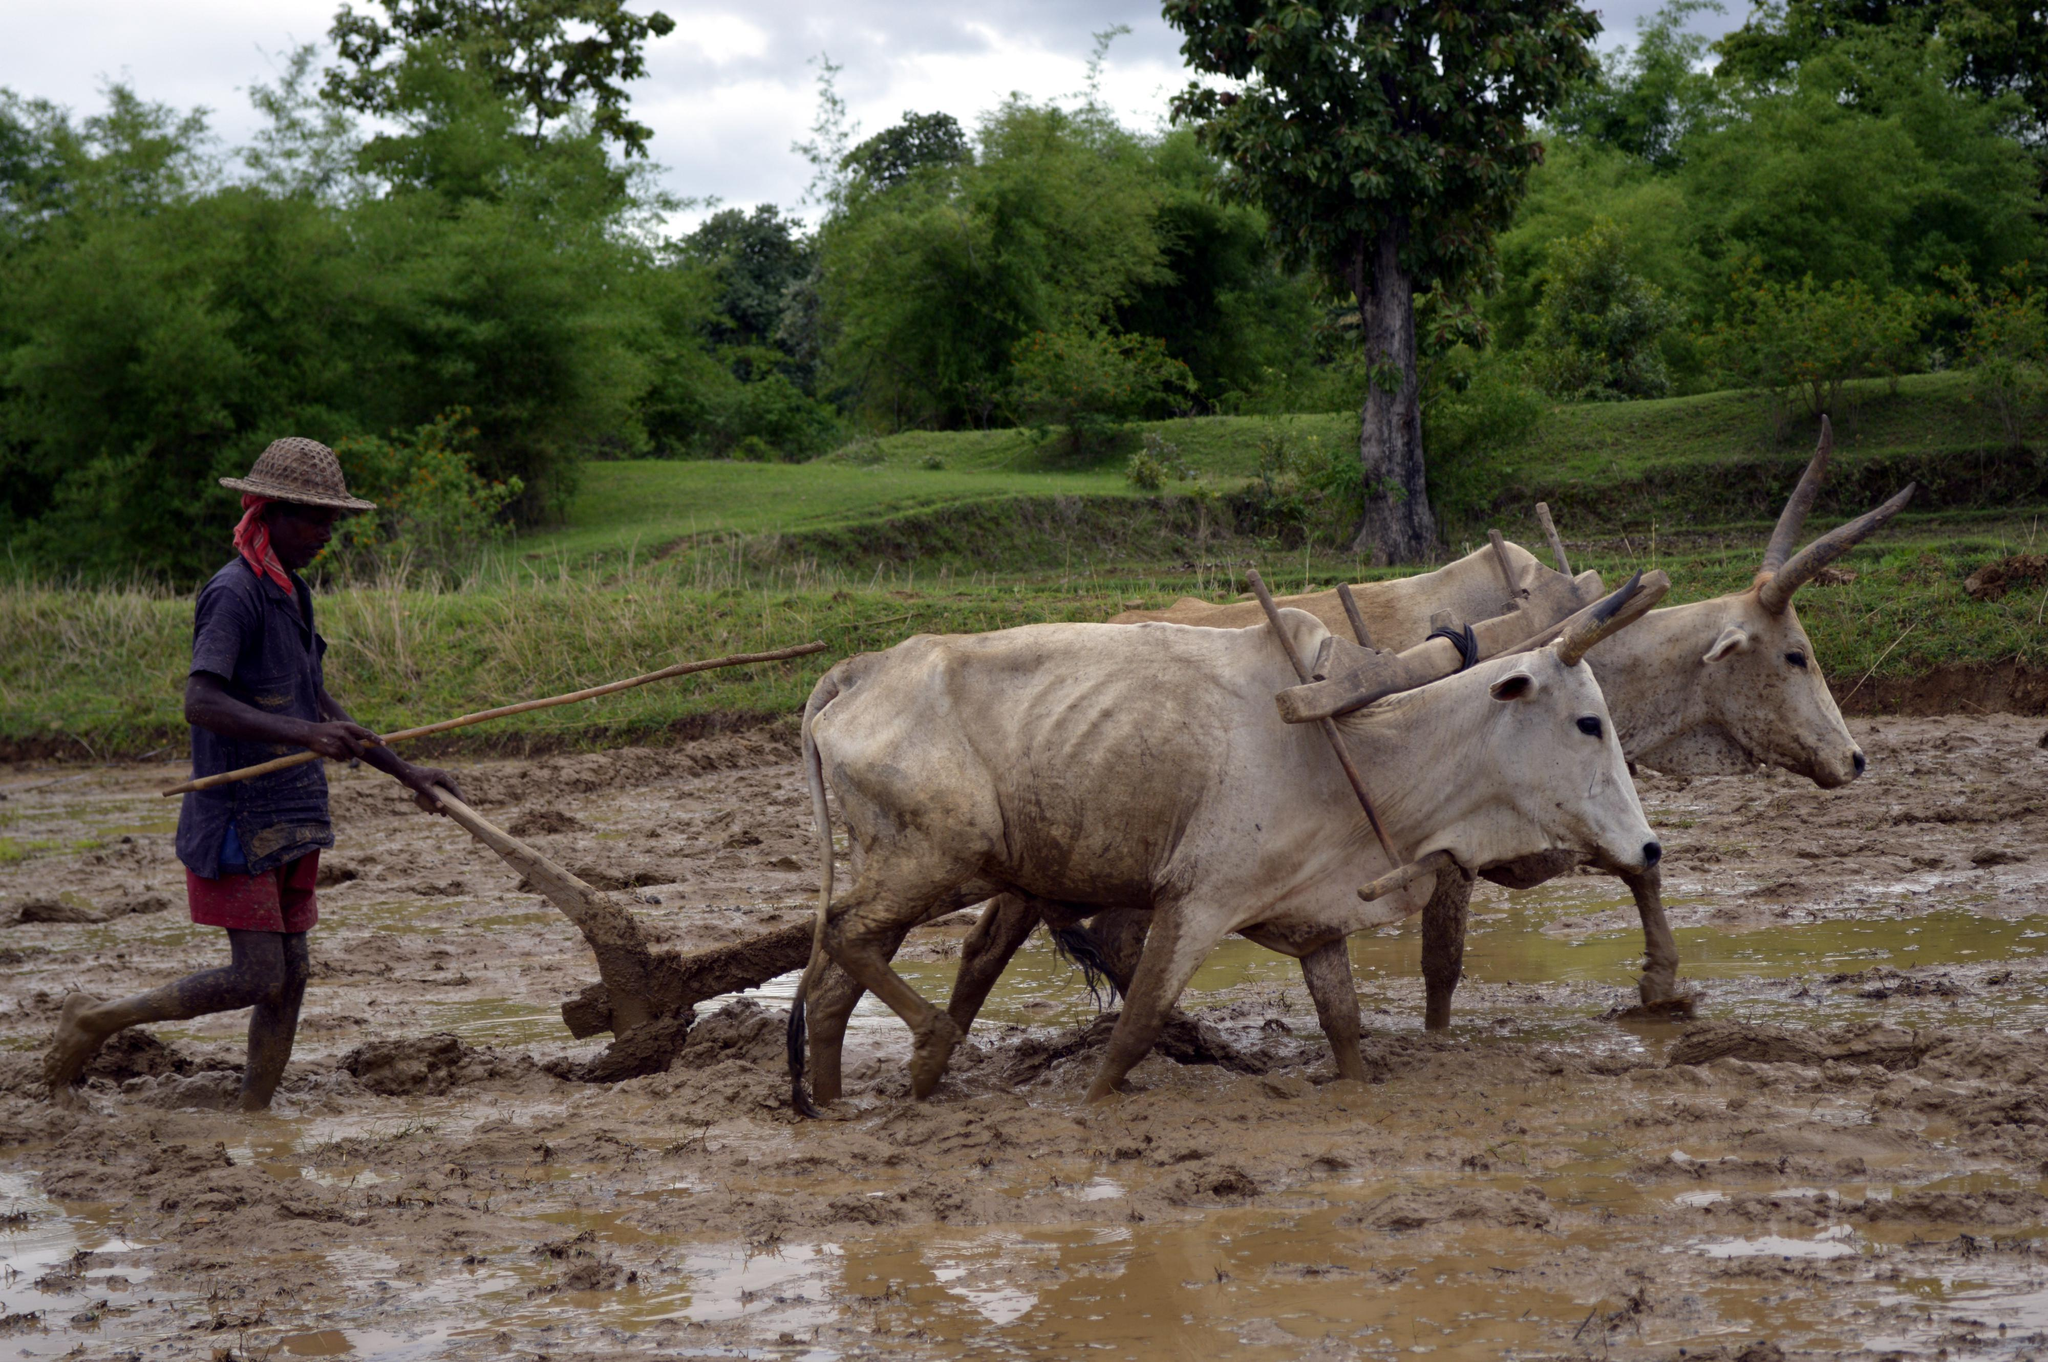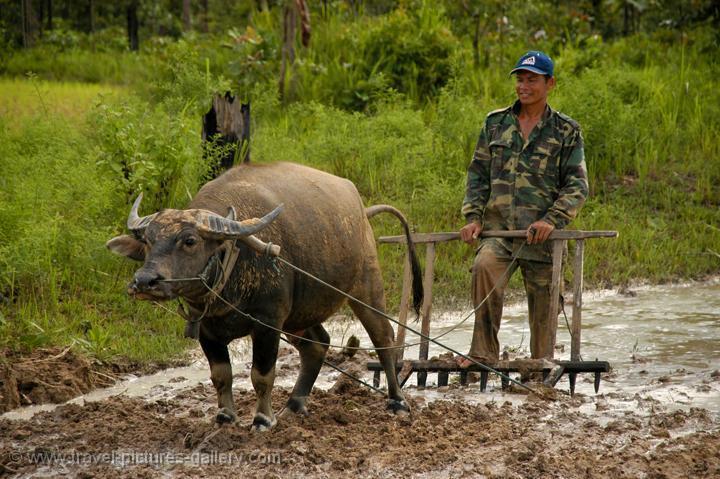The first image is the image on the left, the second image is the image on the right. Assess this claim about the two images: "There are black and brown oxes going right tilting the land as man with a hat follows.". Correct or not? Answer yes or no. No. The first image is the image on the left, the second image is the image on the right. Analyze the images presented: Is the assertion "The humans are to the right of the cows in the left image." valid? Answer yes or no. No. 